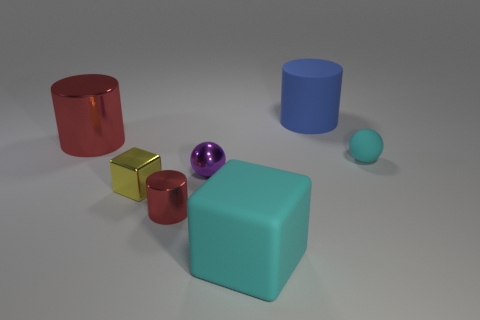What number of other objects are there of the same shape as the large red metal object? Besides the large red cylinder, there are two other cylindrical objects—a smaller red cylinder and a blue cylinder—making for a total of two other objects sharing the same cylindrical shape. 